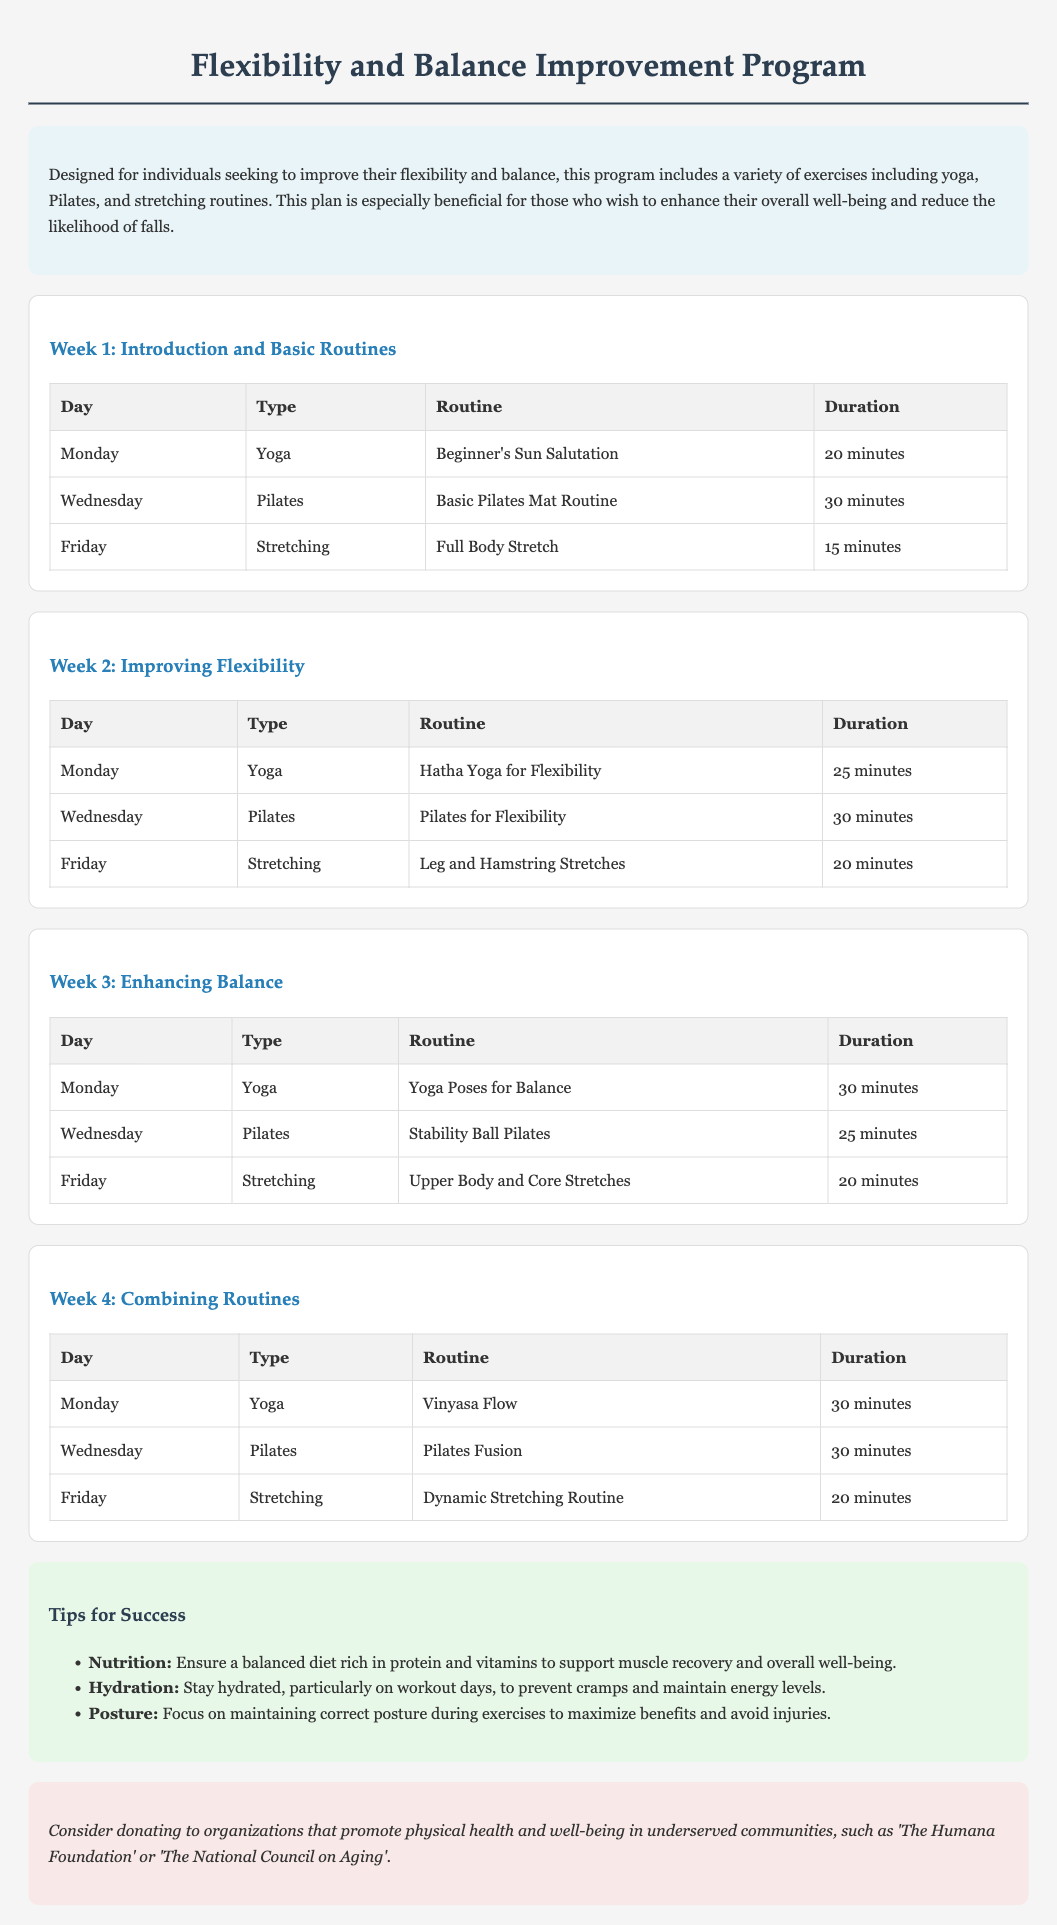What is the duration of the first yoga session? The duration of the first yoga session (Beginner's Sun Salutation) is detailed in the table under Week 1, which is 20 minutes.
Answer: 20 minutes What exercises are included in Week 3? Week 3 includes three specific exercises, as listed in the table: Yoga Poses for Balance, Stability Ball Pilates, and Upper Body and Core Stretches.
Answer: Yoga Poses for Balance, Stability Ball Pilates, Upper Body and Core Stretches How many minutes is the Hatha Yoga session in Week 2? The Hatha Yoga session focuses on flexibility and lasts for 25 minutes, as indicated in the Week 2 table.
Answer: 25 minutes What routine is emphasized in Week 4? The emphasis in Week 4 is on combining routines which consists of Vinyasa Flow, Pilates Fusion, and a Dynamic Stretching Routine, highlighted in the week’s table.
Answer: Combining routines Which day of the week features a Pilates session? Pilates sessions are featured on Wednesdays throughout the month, as indicated in the schedule.
Answer: Wednesday What is the suggested charity organization mentioned? The document suggests donating to 'The Humana Foundation' or 'The National Council on Aging' to promote physical health and well-being.
Answer: The Humana Foundation or The National Council on Aging What type of exercise routine is included on Fridays? Fridays include stretching routines, specifically designated for full body stretches, leg and hamstring stretches, upper body and core stretches, and a dynamic stretching routine across the weeks.
Answer: Stretching What is a key tip for success regarding hydration? It’s mentioned that staying hydrated, especially on workout days, prevents cramps and maintains energy levels, highlighting the importance of hydration.
Answer: Stay hydrated 